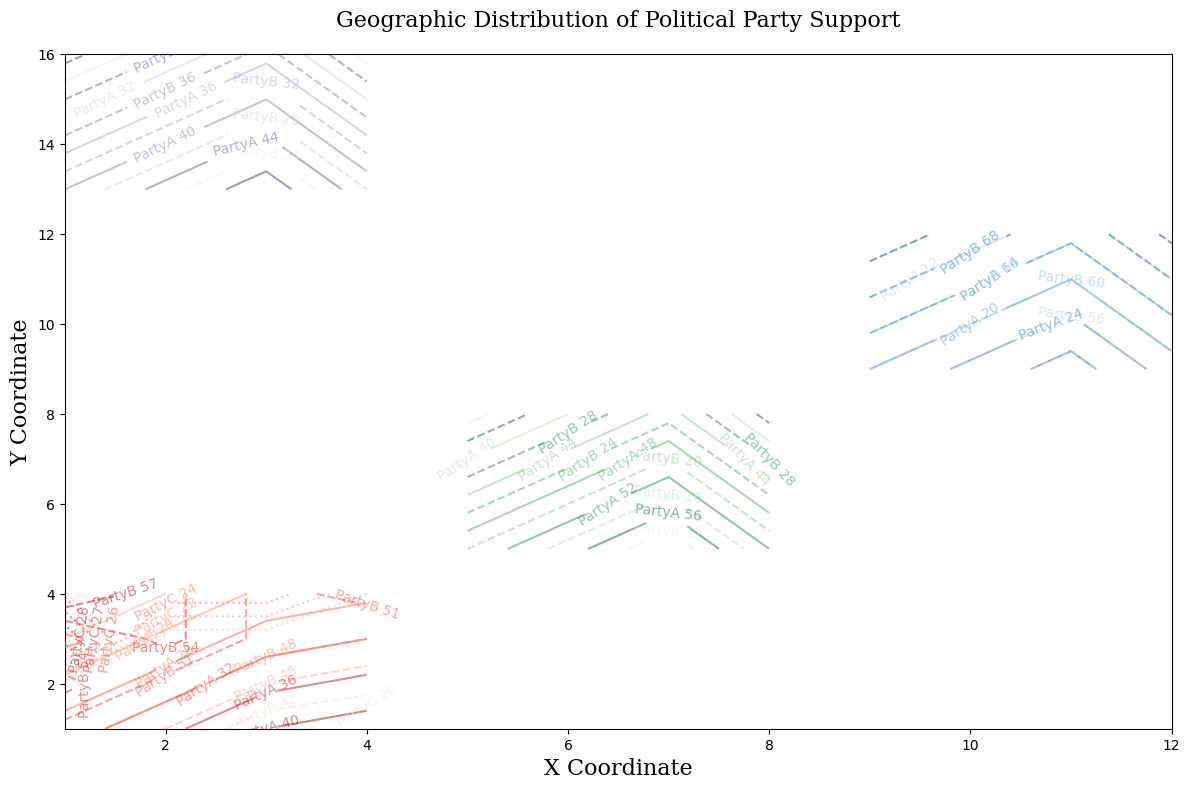What is the general trend of PartyA support in the North region as you move from X = 1 to X = 4? Start from the left (X = 1) and observe the contour lines. At X = 1, values of PartyA support are lower and increase as X increases to the right (X = 4), indicating an upward trend.
Answer: Increasing How does the support for PartyB in the South region compare to PartyB support in the East region? Observe the contour lines for PartyB, represented by dashed lines in both South (green) and East (blue). South has lower values (mostly below 30) compared to East, where values are much higher (often above 60).
Answer: Lower in the South At which coordinates in the West region does PartyC show its highest support level? Look for the highest value on the dotted contours for PartyC in the West (purple). Since PartyC is consistently shown as 30 in the West, the highest support is at all the coordinates, as PartyC values remain constant.
Answer: All coordinates What is the difference in PartyA support at X = 8, Y = 5 and X = 8, Y = 8 in the South region? For X = 8 and Y = 5, PartyA support is shown by the solid green contour lines, which indicate a value around 52. At X = 8 and Y = 8, it's around 37. The difference is 52 - 37 = 15.
Answer: 15 In which region do we see the greatest disparity between PartyA and PartyB support? Observe the contours for both PartyA (solid lines) and PartyB (dashed lines) across all regions. In the East region (blue), the disparity is highest with PartyB support often around 70 while PartyA is significantly lower, sometimes as low as 5.
Answer: East Which party seems to have the most uniform support across the geographic regions? Observe all regions for PartyA, PartyB, and PartyC. PartyC (dotted lines) maintains constant values (20 or 30) across all four regions, indicating the most uniform support.
Answer: PartyC Compare the support of PartyA in the North versus the South region at coordinates where X = 6 and X = 2, respectively. In the North at X = 2 (for any Y), PartyA has values around 30-35. In the South at X = 6, support is higher around 50-55. Thus, PartyA support is notably higher in the South at X = 6.
Answer: Higher in the South at X = 6 What is the mean support for PartyB at the coordinates (X = 3, Y = 3) and (X = 7, Y = 7) across all regions? At (X = 3, Y = 3), PartyB has values of 50 (North) and 20 (South). At (X = 7, Y = 7), PartyB has 20 (South). Mean is calculated as (50 + 20 + 20) / 3 = 90/3 = 30.
Answer: 30 Is there any region where all three parties show equal support at any coordinates? Examine the contour lines carefully. In the West region (purple), at X = 3, Y = 13 and Y = 14, all three Party support values are close to each other (around 30).
Answer: West Where in the North region does PartyA achieve near equal support with PartyB? Look for points where the solid (PartyA) and dashed (PartyB) red contour lines are close to each other in the North. At approximately X = 3, Y = 1, both show values around 40.
Answer: Around X = 3, Y = 1 